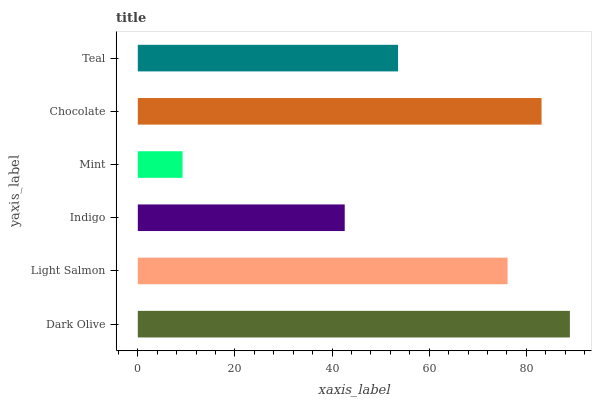Is Mint the minimum?
Answer yes or no. Yes. Is Dark Olive the maximum?
Answer yes or no. Yes. Is Light Salmon the minimum?
Answer yes or no. No. Is Light Salmon the maximum?
Answer yes or no. No. Is Dark Olive greater than Light Salmon?
Answer yes or no. Yes. Is Light Salmon less than Dark Olive?
Answer yes or no. Yes. Is Light Salmon greater than Dark Olive?
Answer yes or no. No. Is Dark Olive less than Light Salmon?
Answer yes or no. No. Is Light Salmon the high median?
Answer yes or no. Yes. Is Teal the low median?
Answer yes or no. Yes. Is Mint the high median?
Answer yes or no. No. Is Mint the low median?
Answer yes or no. No. 